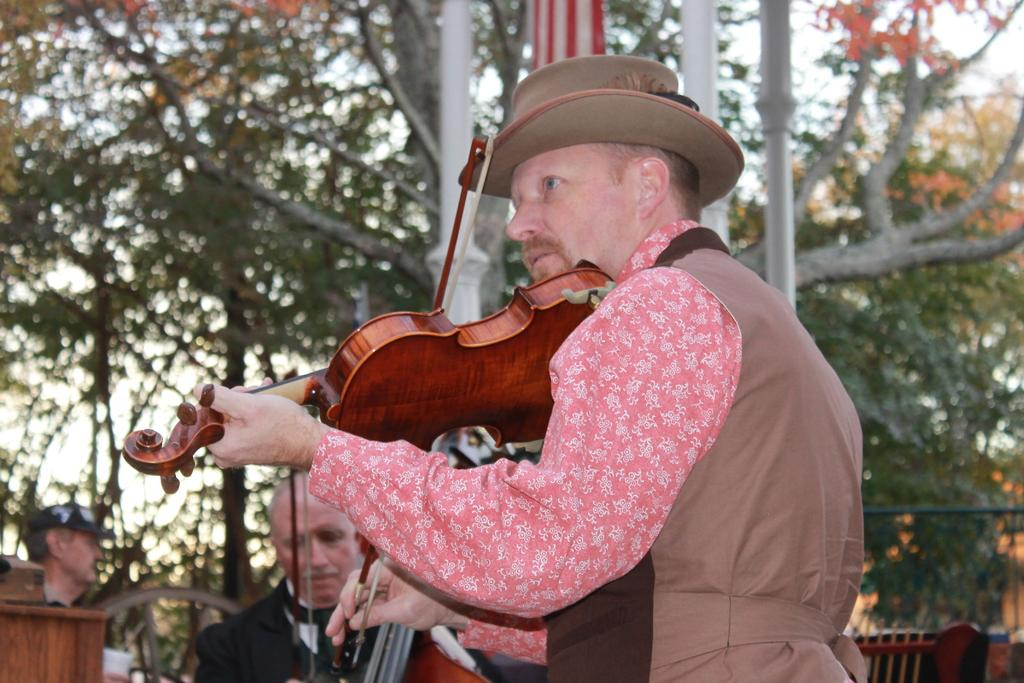How many people are in the image? There are people in the image, but the exact number is not specified. What are the people in the image doing? At least one person is holding a musical instrument. What can be seen in the background of the image? There are trees in the background of the image. What type of cattle can be seen grazing in the background of the image? There is no cattle present in the image; only trees are visible in the background. What religious symbol can be seen in the image? There is no mention of any religious symbols in the image. 